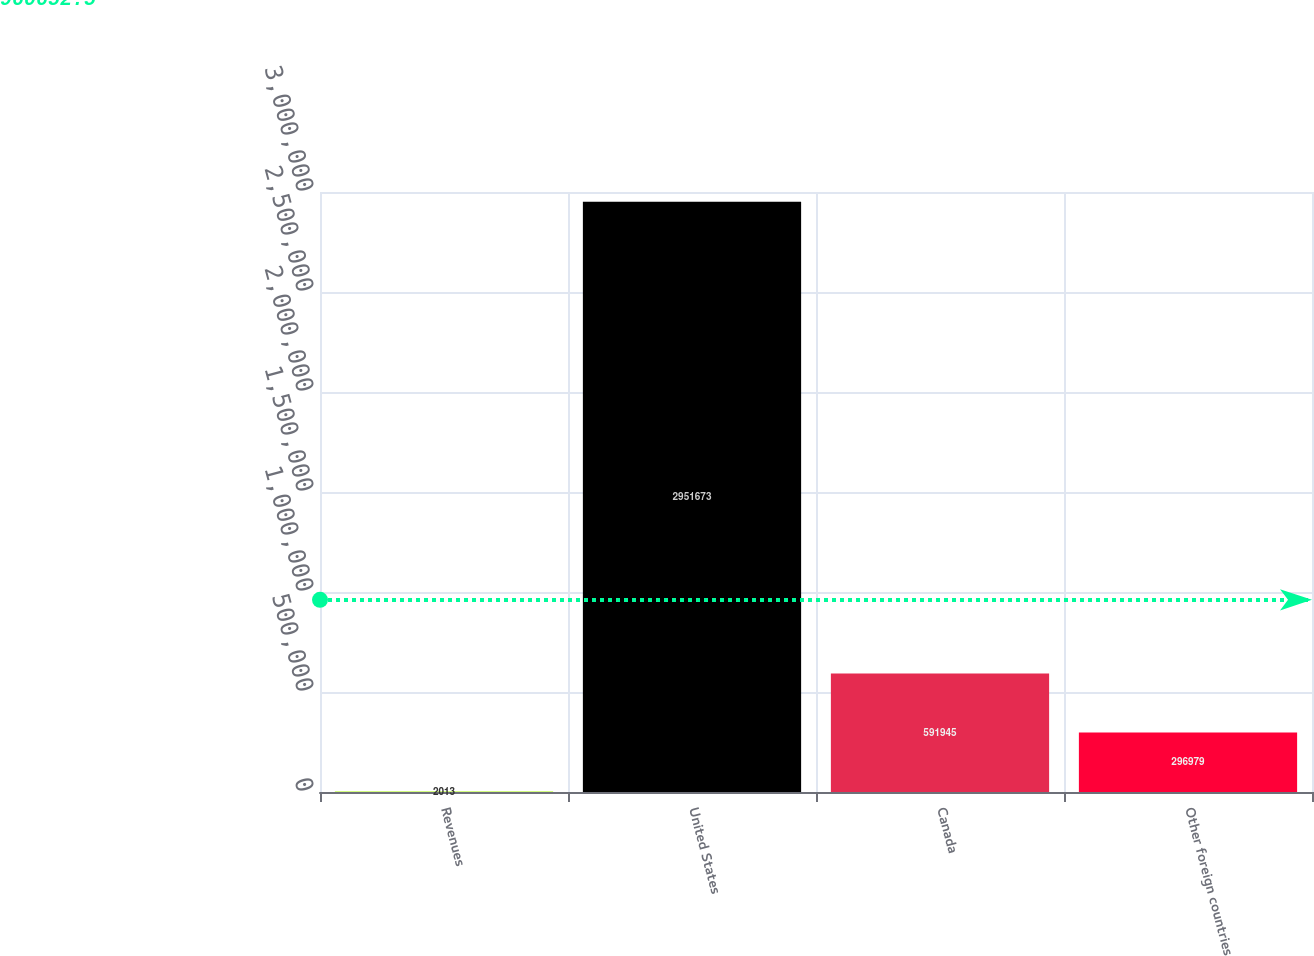<chart> <loc_0><loc_0><loc_500><loc_500><bar_chart><fcel>Revenues<fcel>United States<fcel>Canada<fcel>Other foreign countries<nl><fcel>2013<fcel>2.95167e+06<fcel>591945<fcel>296979<nl></chart> 